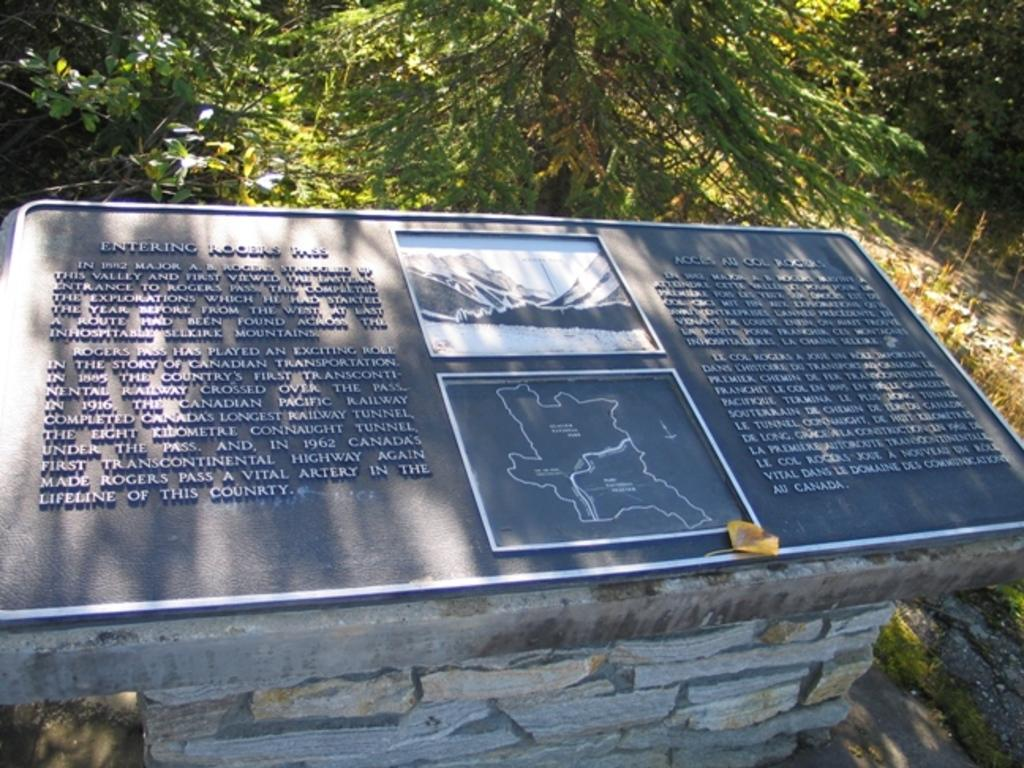What is present on the wall in the image? There is a board with text on the wall. What can be seen in the background of the image? There are trees in the background of the image. What type of collar can be seen on the box in the image? There is no box or collar present in the image. How many toes are visible on the trees in the image? Trees do not have toes, so this question cannot be answered. 